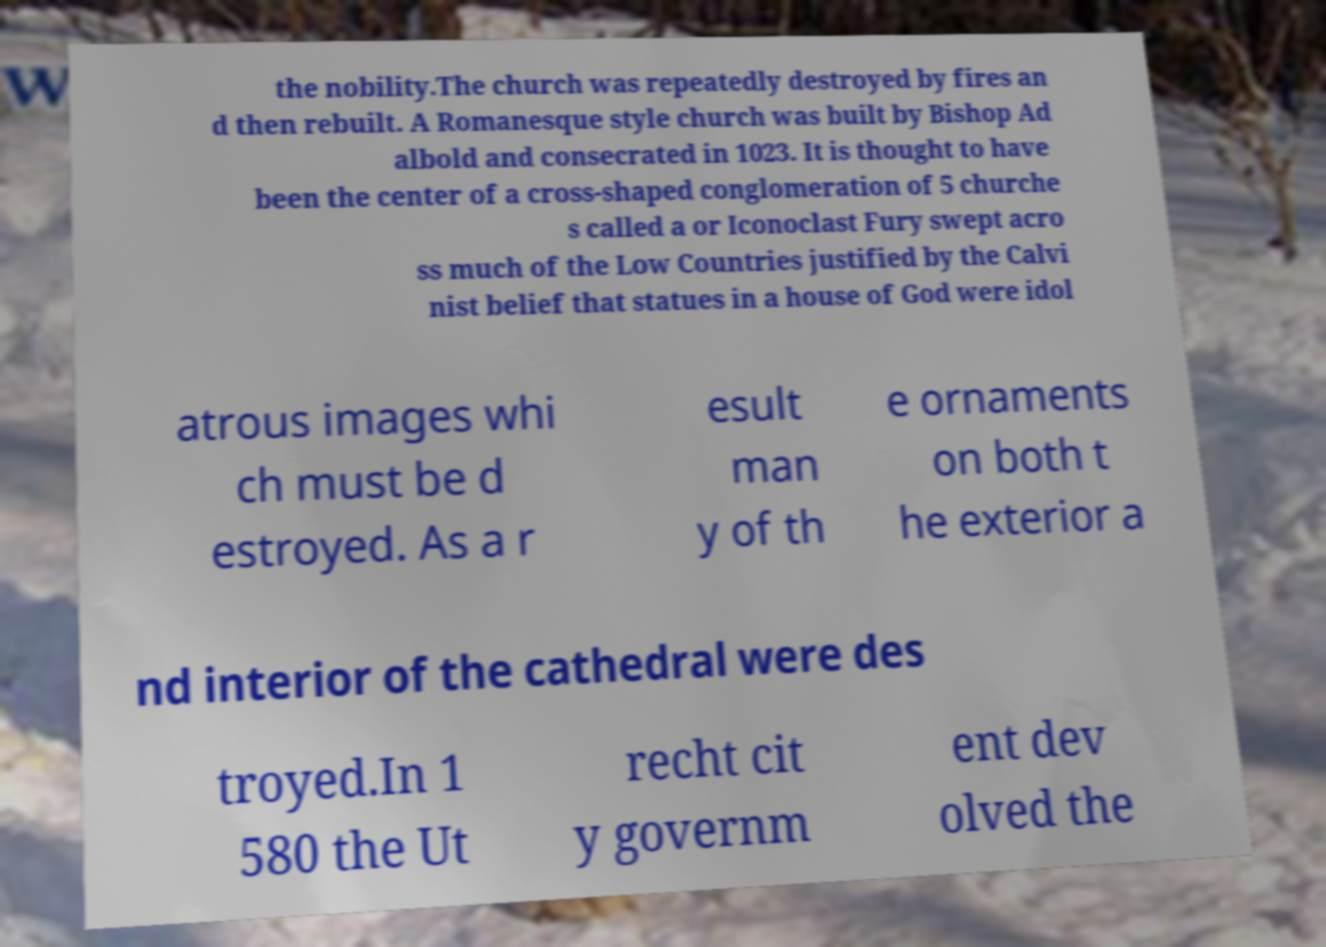For documentation purposes, I need the text within this image transcribed. Could you provide that? the nobility.The church was repeatedly destroyed by fires an d then rebuilt. A Romanesque style church was built by Bishop Ad albold and consecrated in 1023. It is thought to have been the center of a cross-shaped conglomeration of 5 churche s called a or Iconoclast Fury swept acro ss much of the Low Countries justified by the Calvi nist belief that statues in a house of God were idol atrous images whi ch must be d estroyed. As a r esult man y of th e ornaments on both t he exterior a nd interior of the cathedral were des troyed.In 1 580 the Ut recht cit y governm ent dev olved the 